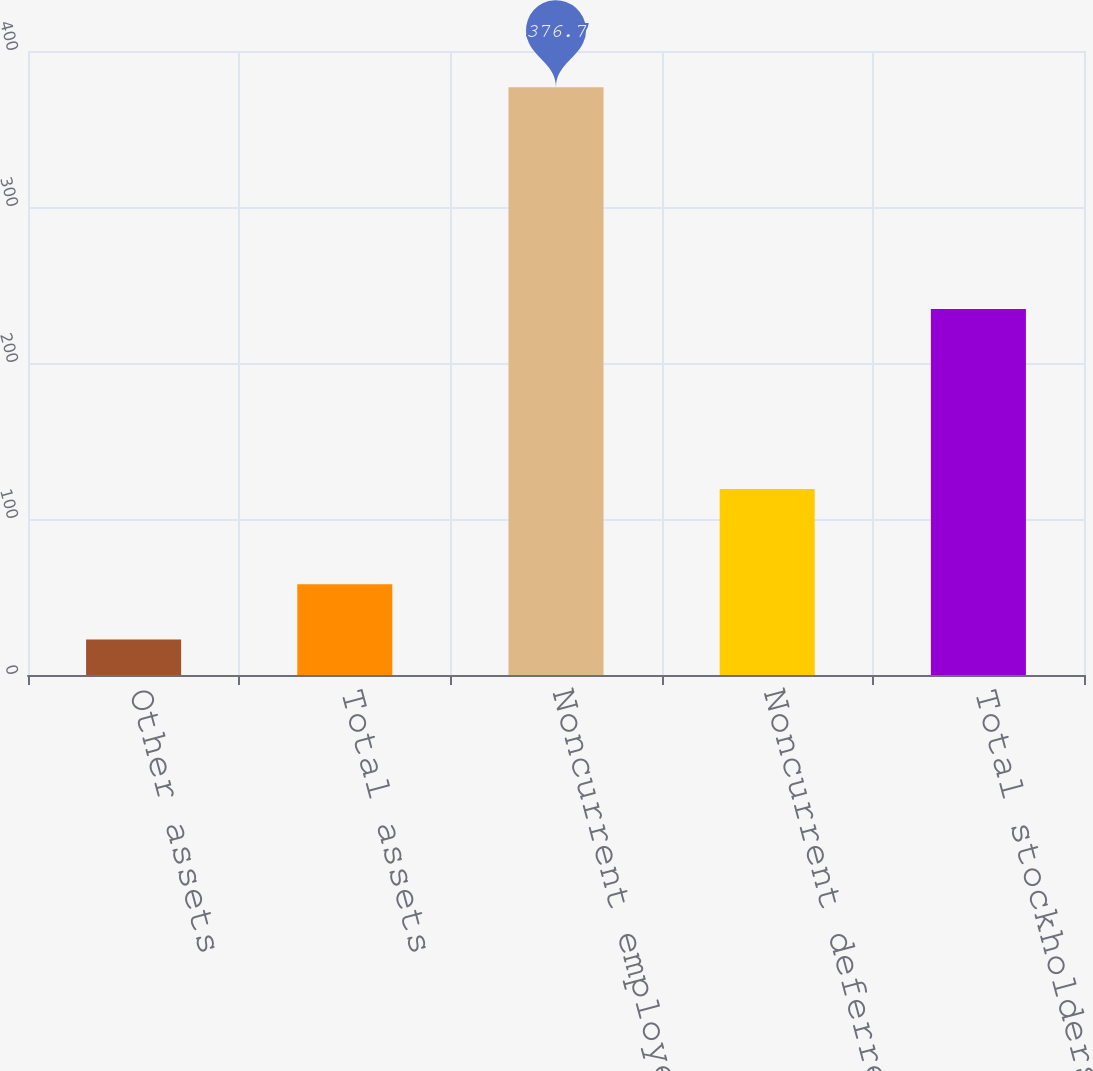Convert chart to OTSL. <chart><loc_0><loc_0><loc_500><loc_500><bar_chart><fcel>Other assets<fcel>Total assets<fcel>Noncurrent employee benefit<fcel>Noncurrent deferred income<fcel>Total stockholders' equity<nl><fcel>22.8<fcel>58.19<fcel>376.7<fcel>119.3<fcel>234.6<nl></chart> 